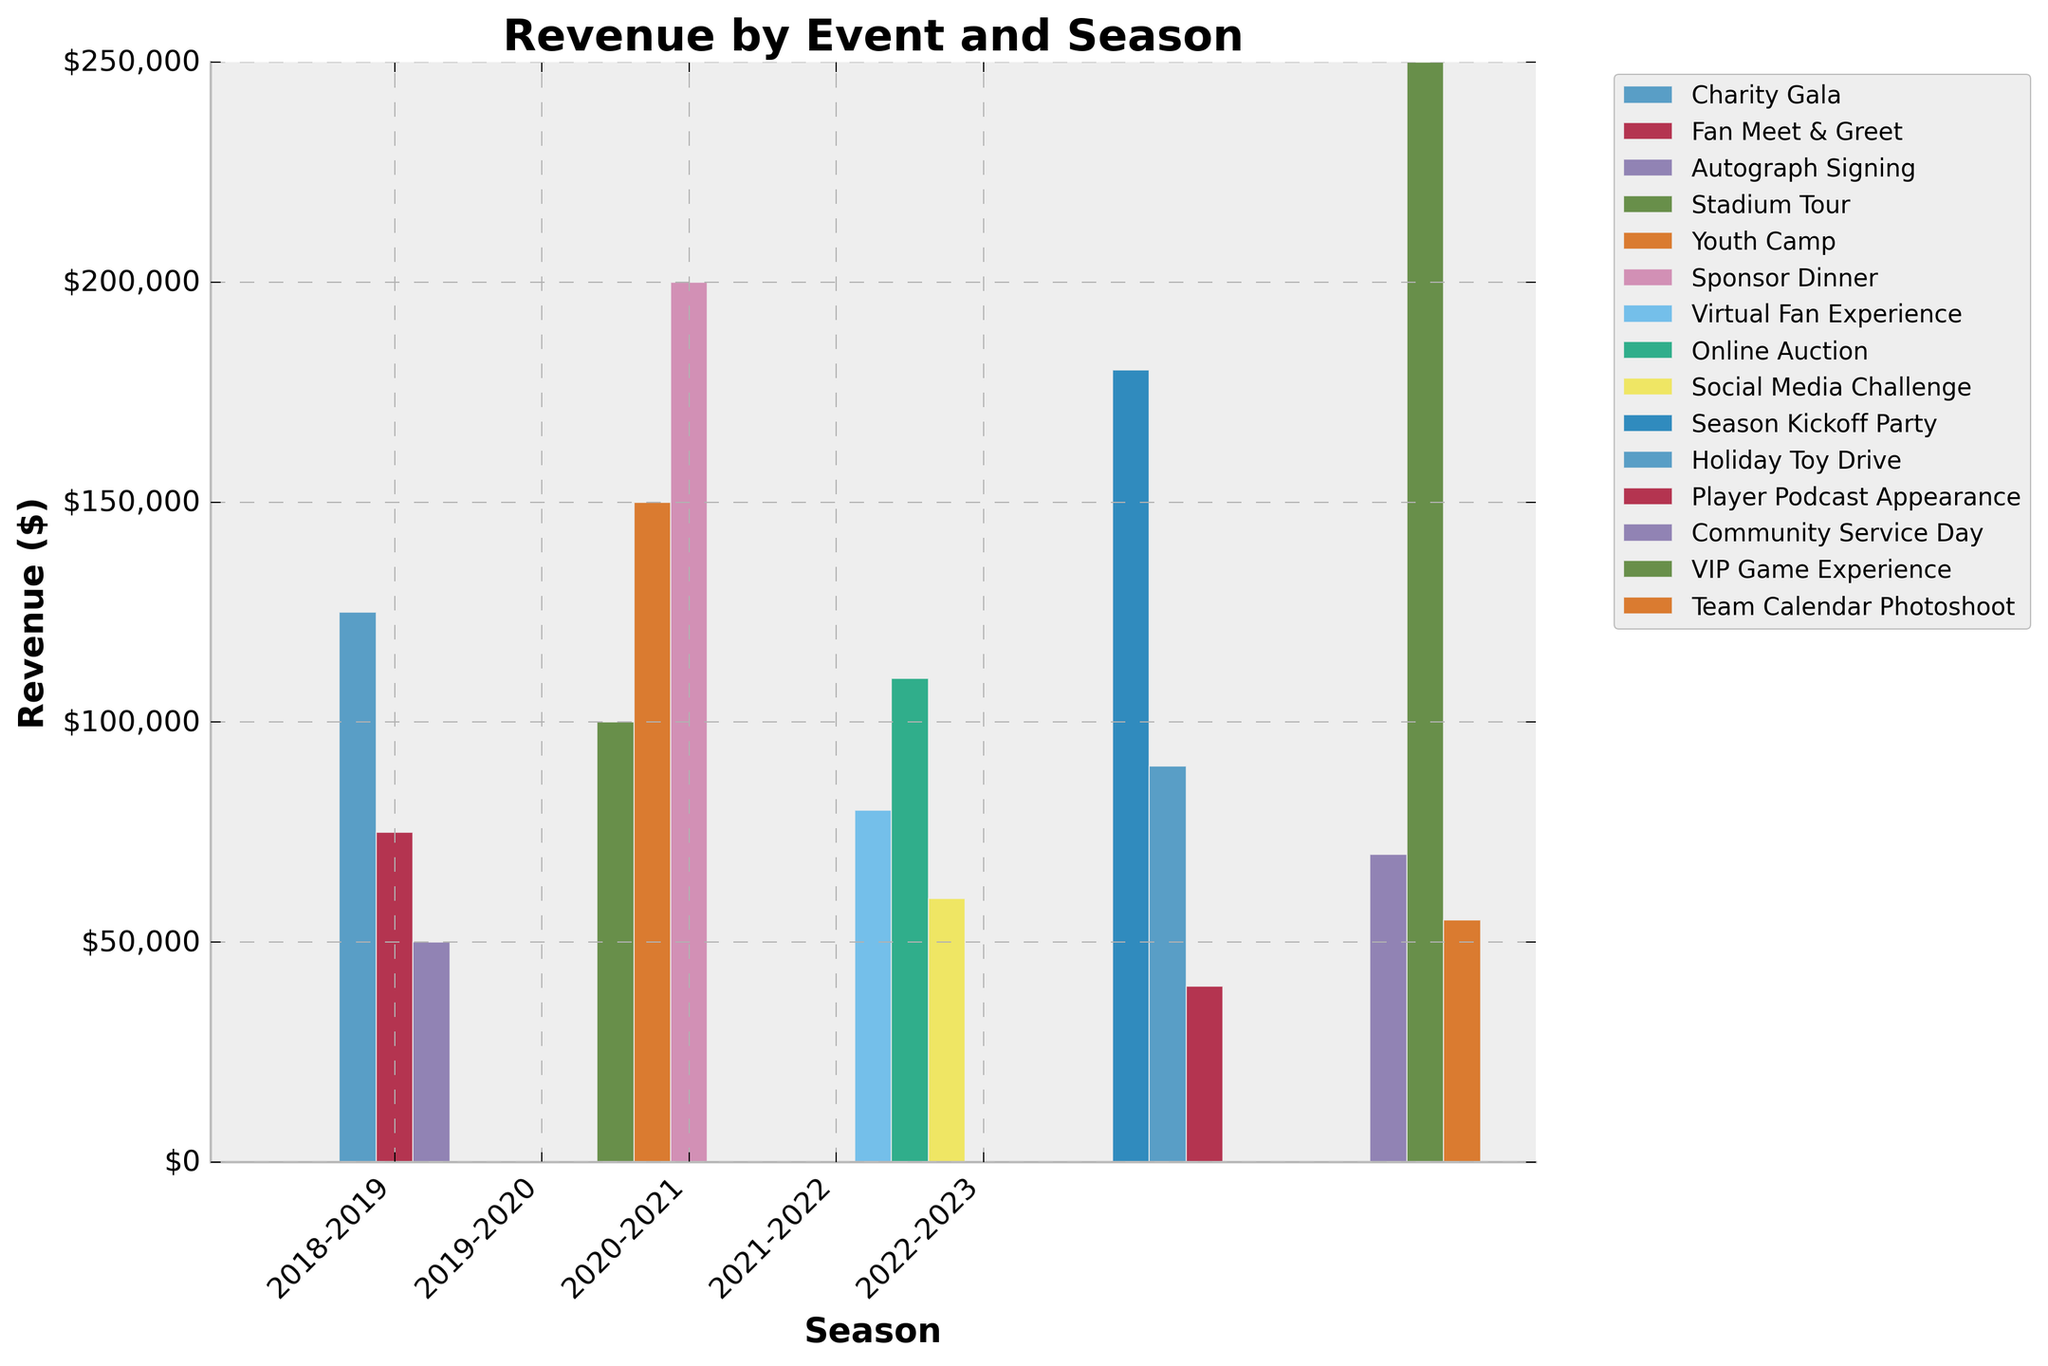Which event generated the highest revenue in the 2022-2023 season? To determine this, look at the bar corresponding to the 2022-2023 season. Among the bars, the "VIP Game Experience" has the tallest bar, indicating the highest revenue.
Answer: VIP Game Experience How much total revenue was generated from all promotional events in the 2018-2019 season? Add the revenues for all events in the 2018-2019 season: Charity Gala ($125,000) + Fan Meet & Greet ($75,000) + Autograph Signing ($50,000). The total is $125,000 + $75,000 + $50,000 = $250,000.
Answer: $250,000 Which season saw the highest overall revenue from all events combined? Compare the total heights of all bars in each season. The sum of all bar heights in the 2019-2020 season is the highest.
Answer: 2019-2020 Does the "Online Auction" generate more revenue than the "Virtual Fan Experience" in the 2020-2021 season? Compare the heights of these two bars for 2020-2021. The "Online Auction" bar is taller than the "Virtual Fan Experience" bar.
Answer: Yes What is the average revenue generated per event in the 2020-2021 season? Calculate the average by summing the revenues from all events in 2020-2021 and dividing by the number of events. ($80,000 + $110,000 + $60,000) / 3 = $83,333.33
Answer: $83,333.33 Compare the revenue generated by "Sponsor Dinner" and "Stadium Tour" in the 2019-2020 season. Which one generated more? Look at the heights of these two bars in the 2019-2020 season. The "Sponsor Dinner" bar is taller.
Answer: Sponsor Dinner Which event in the entire dataset generated the least revenue? Identify the shortest bar across all seasons and events. The "Player Podcast Appearance" in the 2021-2022 season has the shortest bar.
Answer: Player Podcast Appearance If you sum the revenues from "Youth Camp" in 2019-2020 and "Community Service Day" in 2022-2023, what is the total? Add the revenues: Youth Camp ($150,000) + Community Service Day ($70,000). The total is $150,000 + $70,000 = $220,000.
Answer: $220,000 What is the difference in revenue between the highest and lowest earning events in the 2021-2022 season? Subtract the revenue of the lowest earning event from the highest: Season Kickoff Party ($180,000) - Player Podcast Appearance ($40,000). The difference is $140,000.
Answer: $140,000 